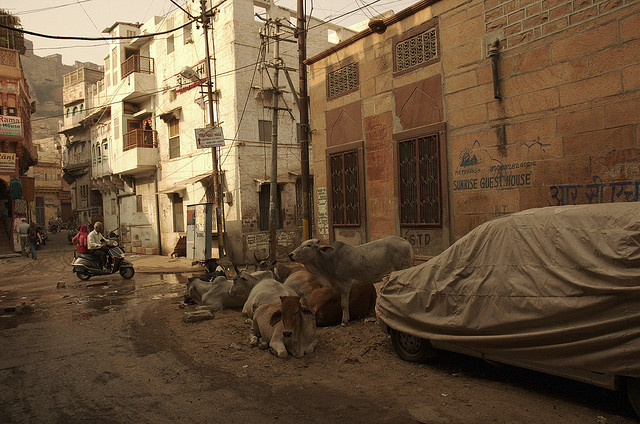What event happened here? Based on the visual clues in the image, such as the presence of stationary cows in the middle of an urban street and a typical local streetscape, the scene likely depicts an everyday street scene rather than a specific 'event'. This suggests day-to-day life in a bustling urban area, possibly in a region where cows roaming freely is a common sight, reflecting cultural and social dynamics of the area. 